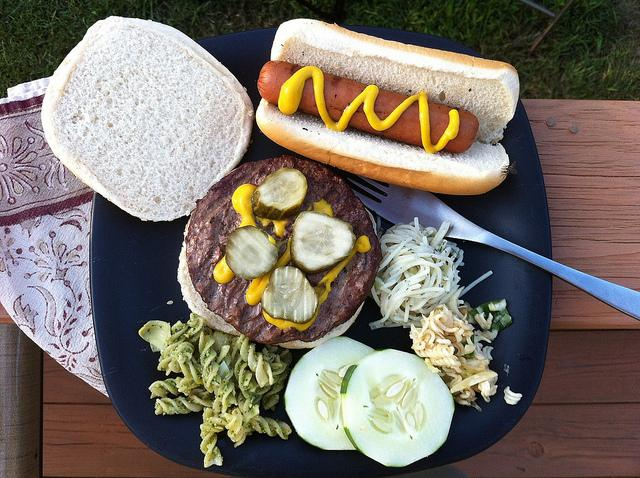How were the meats most likely cooked?

Choices:
A) bbq grill
B) oven
C) toaster
D) stovetop bbq grill 